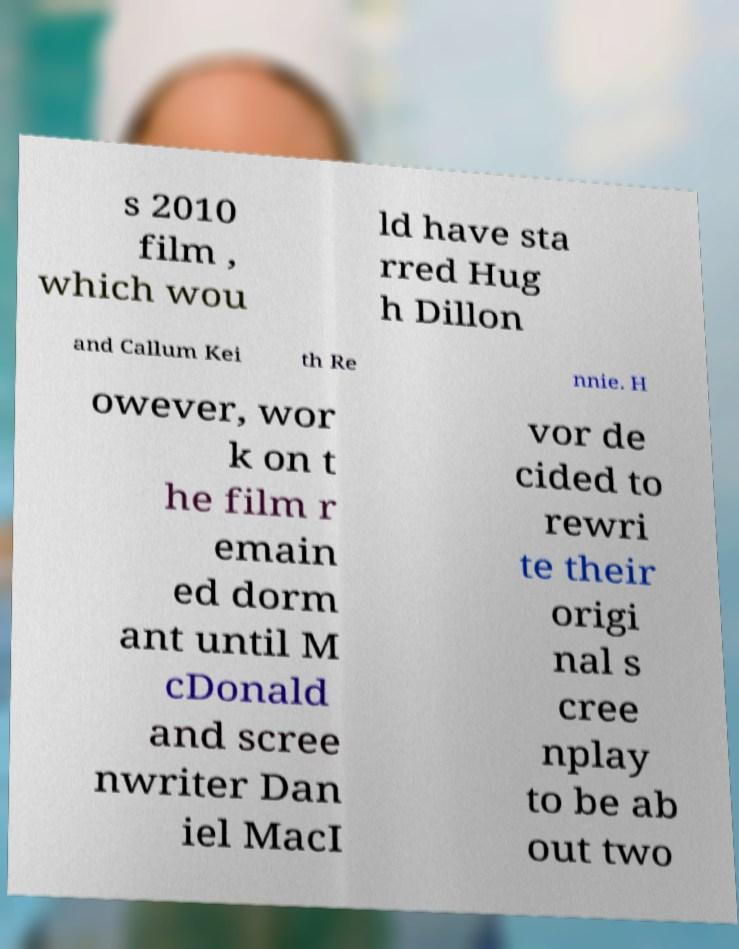Can you accurately transcribe the text from the provided image for me? s 2010 film , which wou ld have sta rred Hug h Dillon and Callum Kei th Re nnie. H owever, wor k on t he film r emain ed dorm ant until M cDonald and scree nwriter Dan iel MacI vor de cided to rewri te their origi nal s cree nplay to be ab out two 